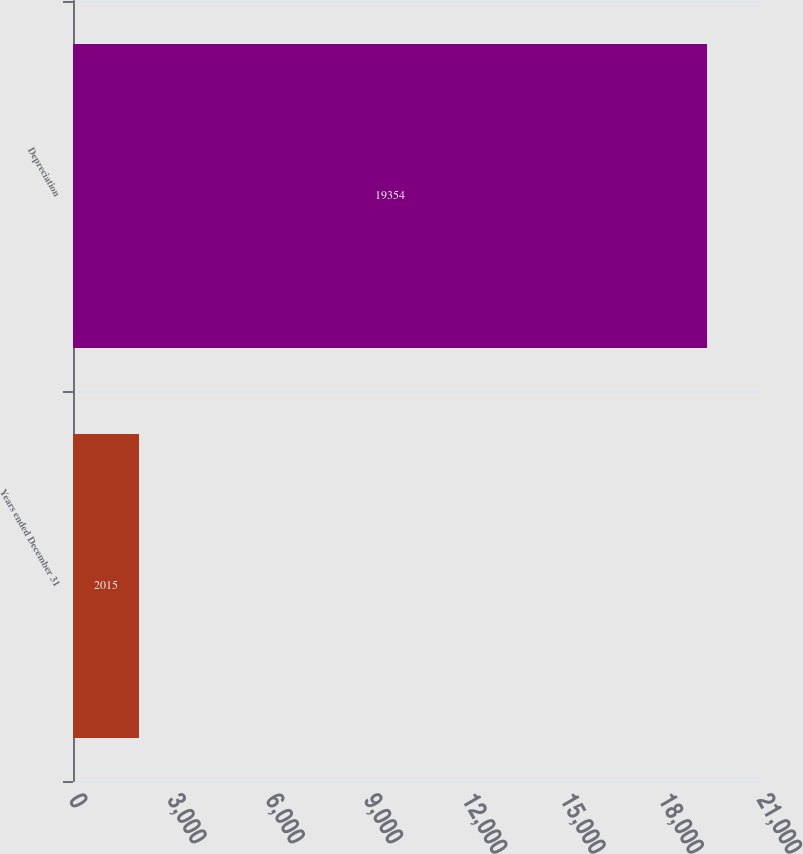Convert chart. <chart><loc_0><loc_0><loc_500><loc_500><bar_chart><fcel>Years ended December 31<fcel>Depreciation<nl><fcel>2015<fcel>19354<nl></chart> 